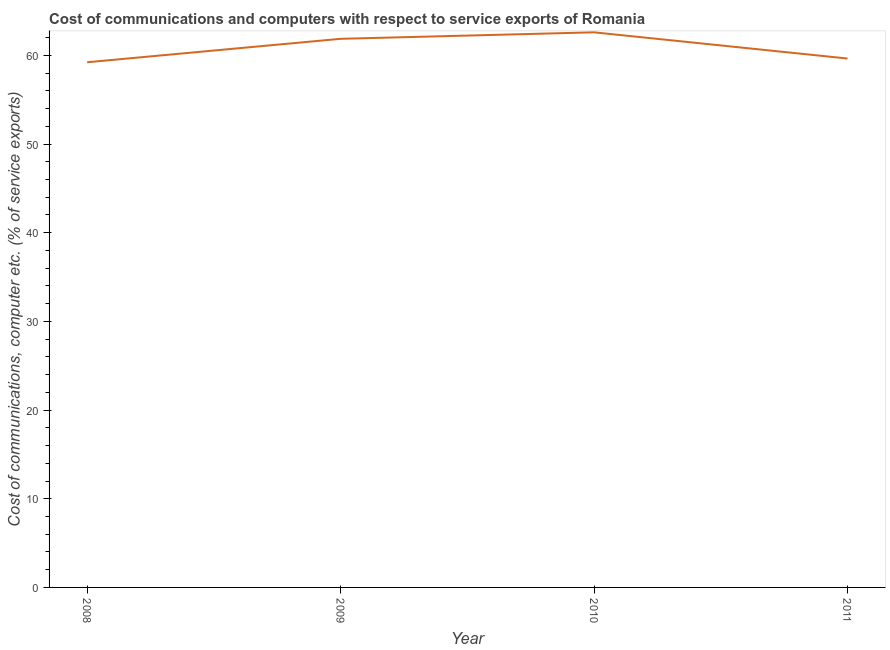What is the cost of communications and computer in 2008?
Your answer should be compact. 59.22. Across all years, what is the maximum cost of communications and computer?
Keep it short and to the point. 62.59. Across all years, what is the minimum cost of communications and computer?
Your answer should be very brief. 59.22. In which year was the cost of communications and computer minimum?
Your answer should be very brief. 2008. What is the sum of the cost of communications and computer?
Your response must be concise. 243.32. What is the difference between the cost of communications and computer in 2009 and 2010?
Provide a short and direct response. -0.73. What is the average cost of communications and computer per year?
Offer a very short reply. 60.83. What is the median cost of communications and computer?
Your response must be concise. 60.75. In how many years, is the cost of communications and computer greater than 28 %?
Keep it short and to the point. 4. Do a majority of the years between 2010 and 2008 (inclusive) have cost of communications and computer greater than 54 %?
Make the answer very short. No. What is the ratio of the cost of communications and computer in 2009 to that in 2011?
Offer a terse response. 1.04. What is the difference between the highest and the second highest cost of communications and computer?
Give a very brief answer. 0.73. What is the difference between the highest and the lowest cost of communications and computer?
Ensure brevity in your answer.  3.37. In how many years, is the cost of communications and computer greater than the average cost of communications and computer taken over all years?
Offer a terse response. 2. Does the cost of communications and computer monotonically increase over the years?
Your answer should be compact. No. How many years are there in the graph?
Your response must be concise. 4. What is the difference between two consecutive major ticks on the Y-axis?
Your answer should be compact. 10. Are the values on the major ticks of Y-axis written in scientific E-notation?
Ensure brevity in your answer.  No. Does the graph contain grids?
Ensure brevity in your answer.  No. What is the title of the graph?
Make the answer very short. Cost of communications and computers with respect to service exports of Romania. What is the label or title of the X-axis?
Keep it short and to the point. Year. What is the label or title of the Y-axis?
Your answer should be compact. Cost of communications, computer etc. (% of service exports). What is the Cost of communications, computer etc. (% of service exports) in 2008?
Provide a succinct answer. 59.22. What is the Cost of communications, computer etc. (% of service exports) of 2009?
Your answer should be very brief. 61.86. What is the Cost of communications, computer etc. (% of service exports) in 2010?
Offer a very short reply. 62.59. What is the Cost of communications, computer etc. (% of service exports) of 2011?
Provide a succinct answer. 59.64. What is the difference between the Cost of communications, computer etc. (% of service exports) in 2008 and 2009?
Ensure brevity in your answer.  -2.64. What is the difference between the Cost of communications, computer etc. (% of service exports) in 2008 and 2010?
Give a very brief answer. -3.37. What is the difference between the Cost of communications, computer etc. (% of service exports) in 2008 and 2011?
Your answer should be compact. -0.42. What is the difference between the Cost of communications, computer etc. (% of service exports) in 2009 and 2010?
Your answer should be very brief. -0.73. What is the difference between the Cost of communications, computer etc. (% of service exports) in 2009 and 2011?
Offer a very short reply. 2.22. What is the difference between the Cost of communications, computer etc. (% of service exports) in 2010 and 2011?
Make the answer very short. 2.95. What is the ratio of the Cost of communications, computer etc. (% of service exports) in 2008 to that in 2009?
Provide a short and direct response. 0.96. What is the ratio of the Cost of communications, computer etc. (% of service exports) in 2008 to that in 2010?
Your answer should be very brief. 0.95. What is the ratio of the Cost of communications, computer etc. (% of service exports) in 2008 to that in 2011?
Give a very brief answer. 0.99. What is the ratio of the Cost of communications, computer etc. (% of service exports) in 2009 to that in 2010?
Your answer should be compact. 0.99. What is the ratio of the Cost of communications, computer etc. (% of service exports) in 2009 to that in 2011?
Your answer should be very brief. 1.04. 